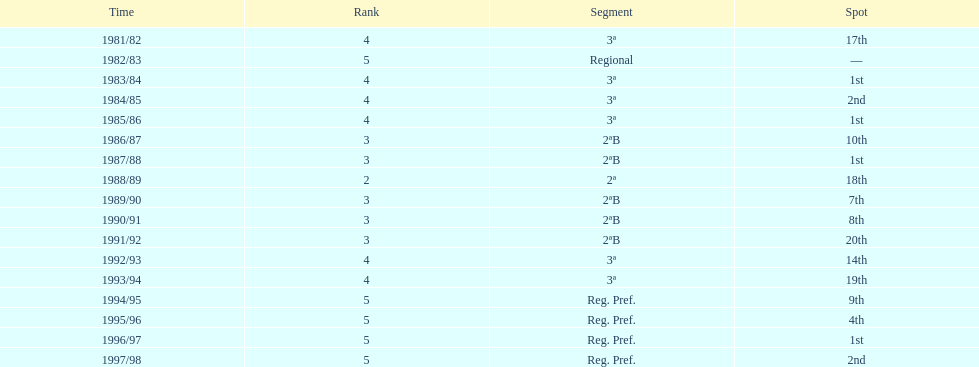What were the number of times second place was earned? 2. 